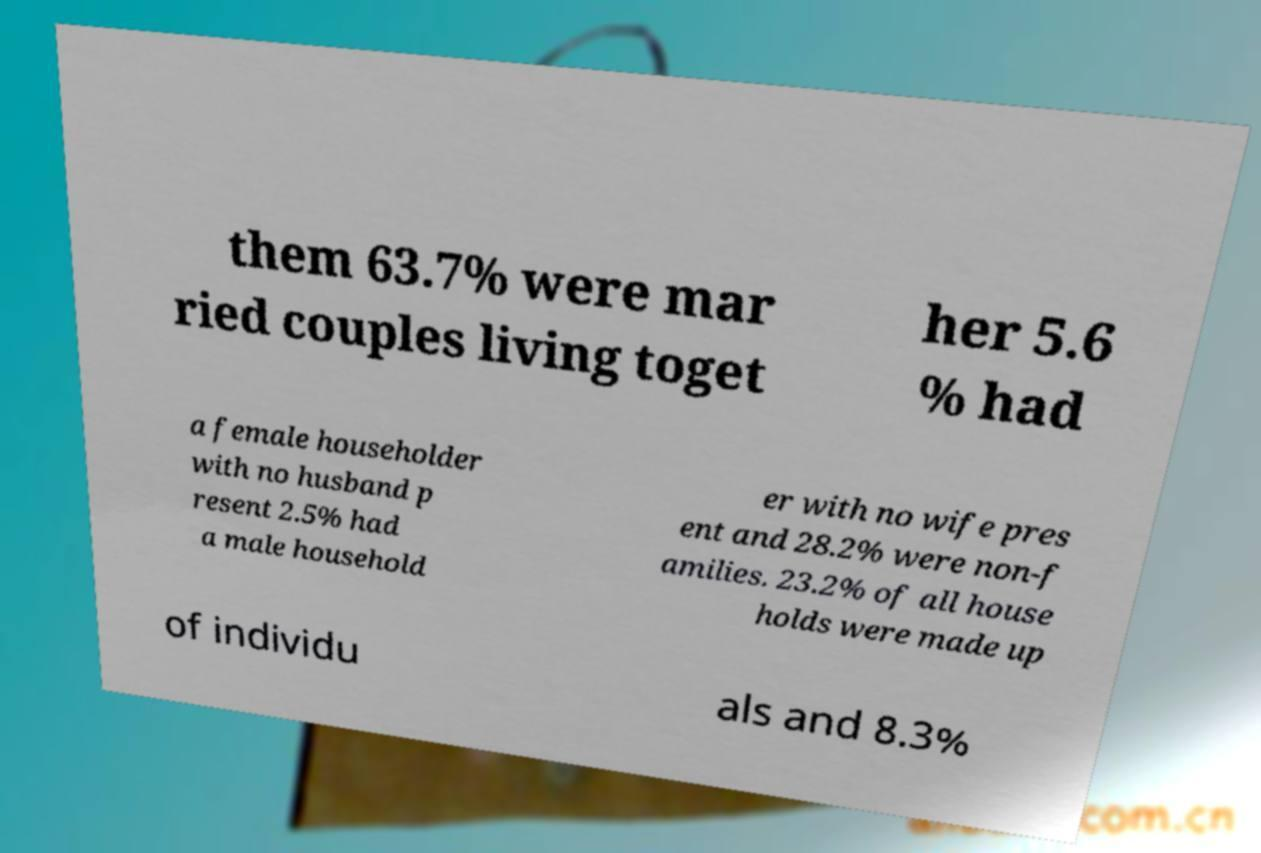Can you read and provide the text displayed in the image?This photo seems to have some interesting text. Can you extract and type it out for me? them 63.7% were mar ried couples living toget her 5.6 % had a female householder with no husband p resent 2.5% had a male household er with no wife pres ent and 28.2% were non-f amilies. 23.2% of all house holds were made up of individu als and 8.3% 